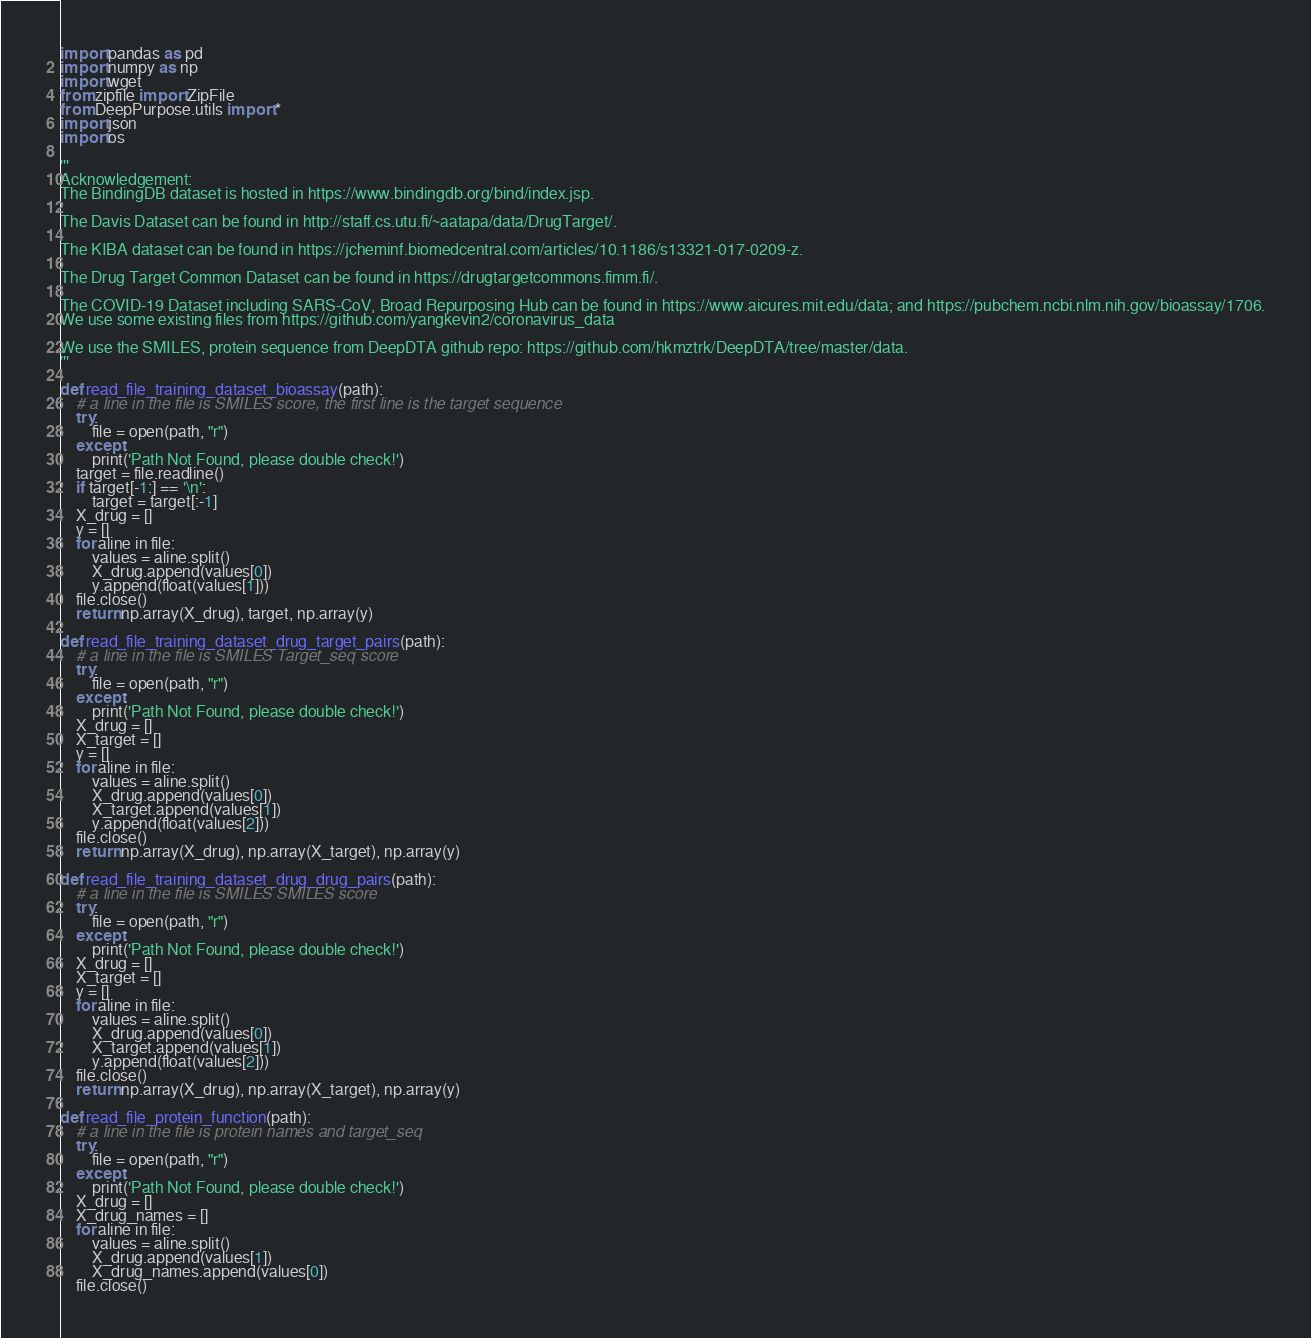<code> <loc_0><loc_0><loc_500><loc_500><_Python_>import pandas as pd
import numpy as np
import wget
from zipfile import ZipFile
from DeepPurpose.utils import *
import json
import os

'''
Acknowledgement:
The BindingDB dataset is hosted in https://www.bindingdb.org/bind/index.jsp.

The Davis Dataset can be found in http://staff.cs.utu.fi/~aatapa/data/DrugTarget/.

The KIBA dataset can be found in https://jcheminf.biomedcentral.com/articles/10.1186/s13321-017-0209-z.

The Drug Target Common Dataset can be found in https://drugtargetcommons.fimm.fi/.

The COVID-19 Dataset including SARS-CoV, Broad Repurposing Hub can be found in https://www.aicures.mit.edu/data; and https://pubchem.ncbi.nlm.nih.gov/bioassay/1706.
We use some existing files from https://github.com/yangkevin2/coronavirus_data

We use the SMILES, protein sequence from DeepDTA github repo: https://github.com/hkmztrk/DeepDTA/tree/master/data.
'''

def read_file_training_dataset_bioassay(path):
	# a line in the file is SMILES score, the first line is the target sequence
	try:
		file = open(path, "r")
	except:
		print('Path Not Found, please double check!')
	target = file.readline()
	if target[-1:] == '\n':
		target = target[:-1]
	X_drug = []
	y = []
	for aline in file:
		values = aline.split()
		X_drug.append(values[0])
		y.append(float(values[1]))
	file.close()
	return np.array(X_drug), target, np.array(y)

def read_file_training_dataset_drug_target_pairs(path):
	# a line in the file is SMILES Target_seq score
	try:
		file = open(path, "r")
	except:
		print('Path Not Found, please double check!')
	X_drug = []
	X_target = []
	y = []
	for aline in file:
		values = aline.split()
		X_drug.append(values[0])
		X_target.append(values[1])
		y.append(float(values[2]))
	file.close()
	return np.array(X_drug), np.array(X_target), np.array(y)

def read_file_training_dataset_drug_drug_pairs(path):
	# a line in the file is SMILES SMILES score
	try:
		file = open(path, "r")
	except:
		print('Path Not Found, please double check!')
	X_drug = []
	X_target = []
	y = []
	for aline in file:
		values = aline.split()
		X_drug.append(values[0])
		X_target.append(values[1])
		y.append(float(values[2]))
	file.close()
	return np.array(X_drug), np.array(X_target), np.array(y)

def read_file_protein_function(path):
	# a line in the file is protein names and target_seq
	try:
		file = open(path, "r")
	except:
		print('Path Not Found, please double check!')
	X_drug = []
	X_drug_names = []
	for aline in file:
		values = aline.split()
		X_drug.append(values[1])
		X_drug_names.append(values[0])
	file.close()</code> 